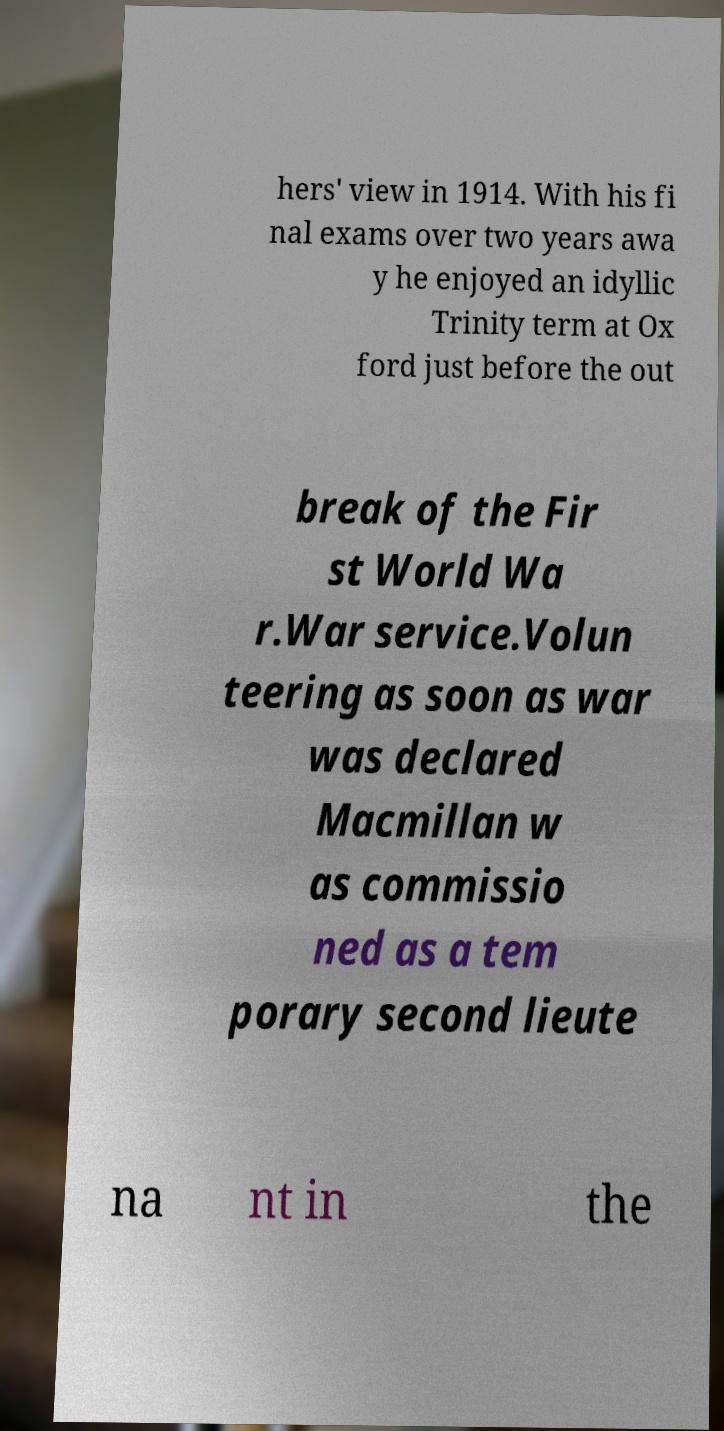For documentation purposes, I need the text within this image transcribed. Could you provide that? hers' view in 1914. With his fi nal exams over two years awa y he enjoyed an idyllic Trinity term at Ox ford just before the out break of the Fir st World Wa r.War service.Volun teering as soon as war was declared Macmillan w as commissio ned as a tem porary second lieute na nt in the 